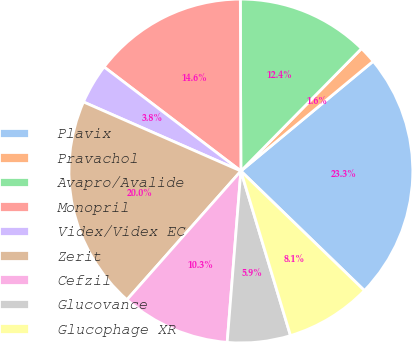<chart> <loc_0><loc_0><loc_500><loc_500><pie_chart><fcel>Plavix<fcel>Pravachol<fcel>Avapro/Avalide<fcel>Monopril<fcel>Videx/Videx EC<fcel>Zerit<fcel>Cefzil<fcel>Glucovance<fcel>Glucophage XR<nl><fcel>23.26%<fcel>1.6%<fcel>12.43%<fcel>14.6%<fcel>3.77%<fcel>20.05%<fcel>10.26%<fcel>5.93%<fcel>8.1%<nl></chart> 